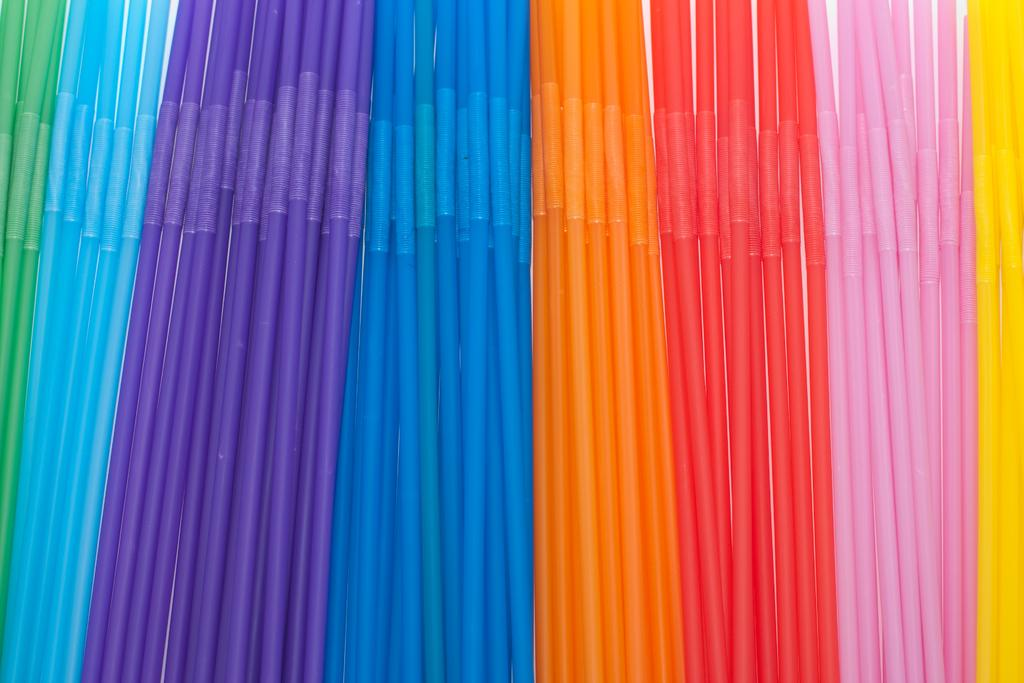What type of objects in the image resemble straws? There are objects in the image that resemble straws. Can you describe the appearance of these straw-like objects? The straw-like objects are in different colors. What type of baby can be seen playing in the rain in the image? There is no baby or rain present in the image; it only features objects that resemble straws in different colors. 